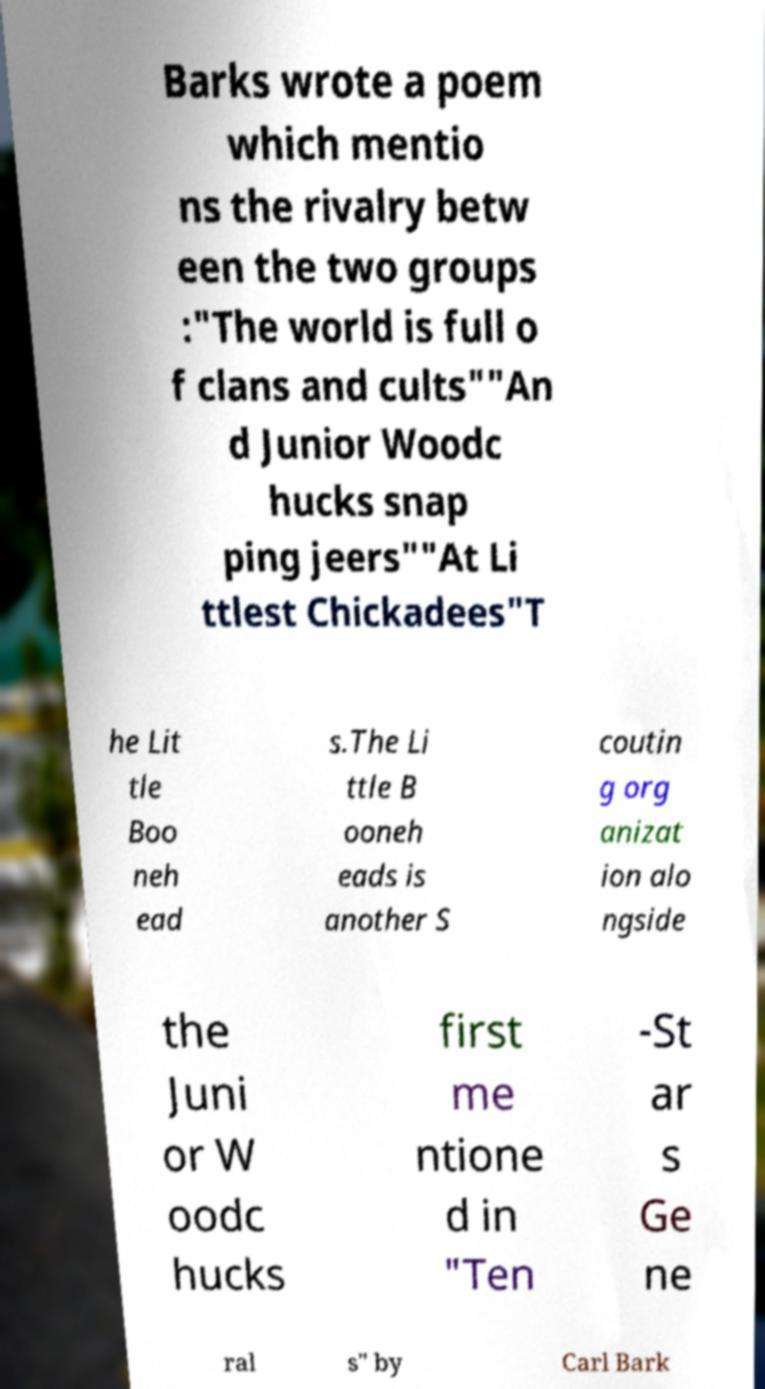There's text embedded in this image that I need extracted. Can you transcribe it verbatim? Barks wrote a poem which mentio ns the rivalry betw een the two groups :"The world is full o f clans and cults""An d Junior Woodc hucks snap ping jeers""At Li ttlest Chickadees"T he Lit tle Boo neh ead s.The Li ttle B ooneh eads is another S coutin g org anizat ion alo ngside the Juni or W oodc hucks first me ntione d in "Ten -St ar s Ge ne ral s" by Carl Bark 